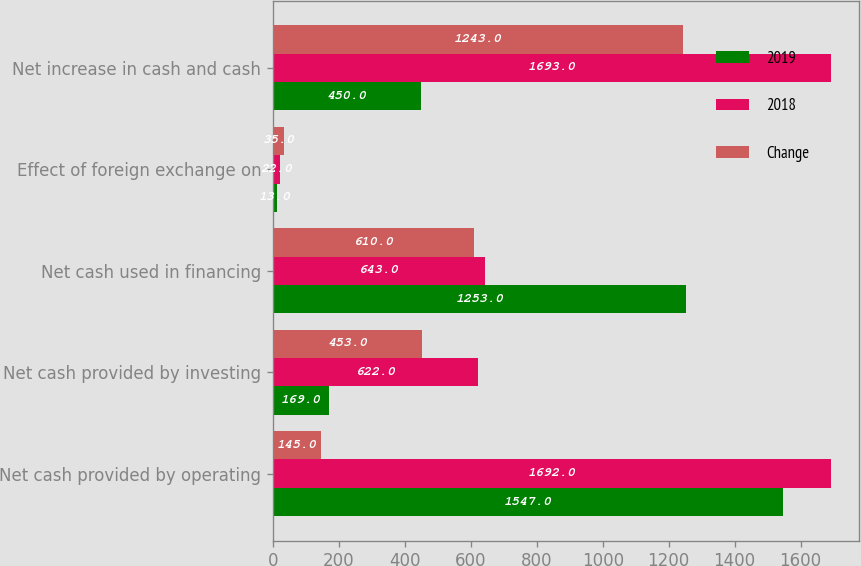<chart> <loc_0><loc_0><loc_500><loc_500><stacked_bar_chart><ecel><fcel>Net cash provided by operating<fcel>Net cash provided by investing<fcel>Net cash used in financing<fcel>Effect of foreign exchange on<fcel>Net increase in cash and cash<nl><fcel>2019<fcel>1547<fcel>169<fcel>1253<fcel>13<fcel>450<nl><fcel>2018<fcel>1692<fcel>622<fcel>643<fcel>22<fcel>1693<nl><fcel>Change<fcel>145<fcel>453<fcel>610<fcel>35<fcel>1243<nl></chart> 